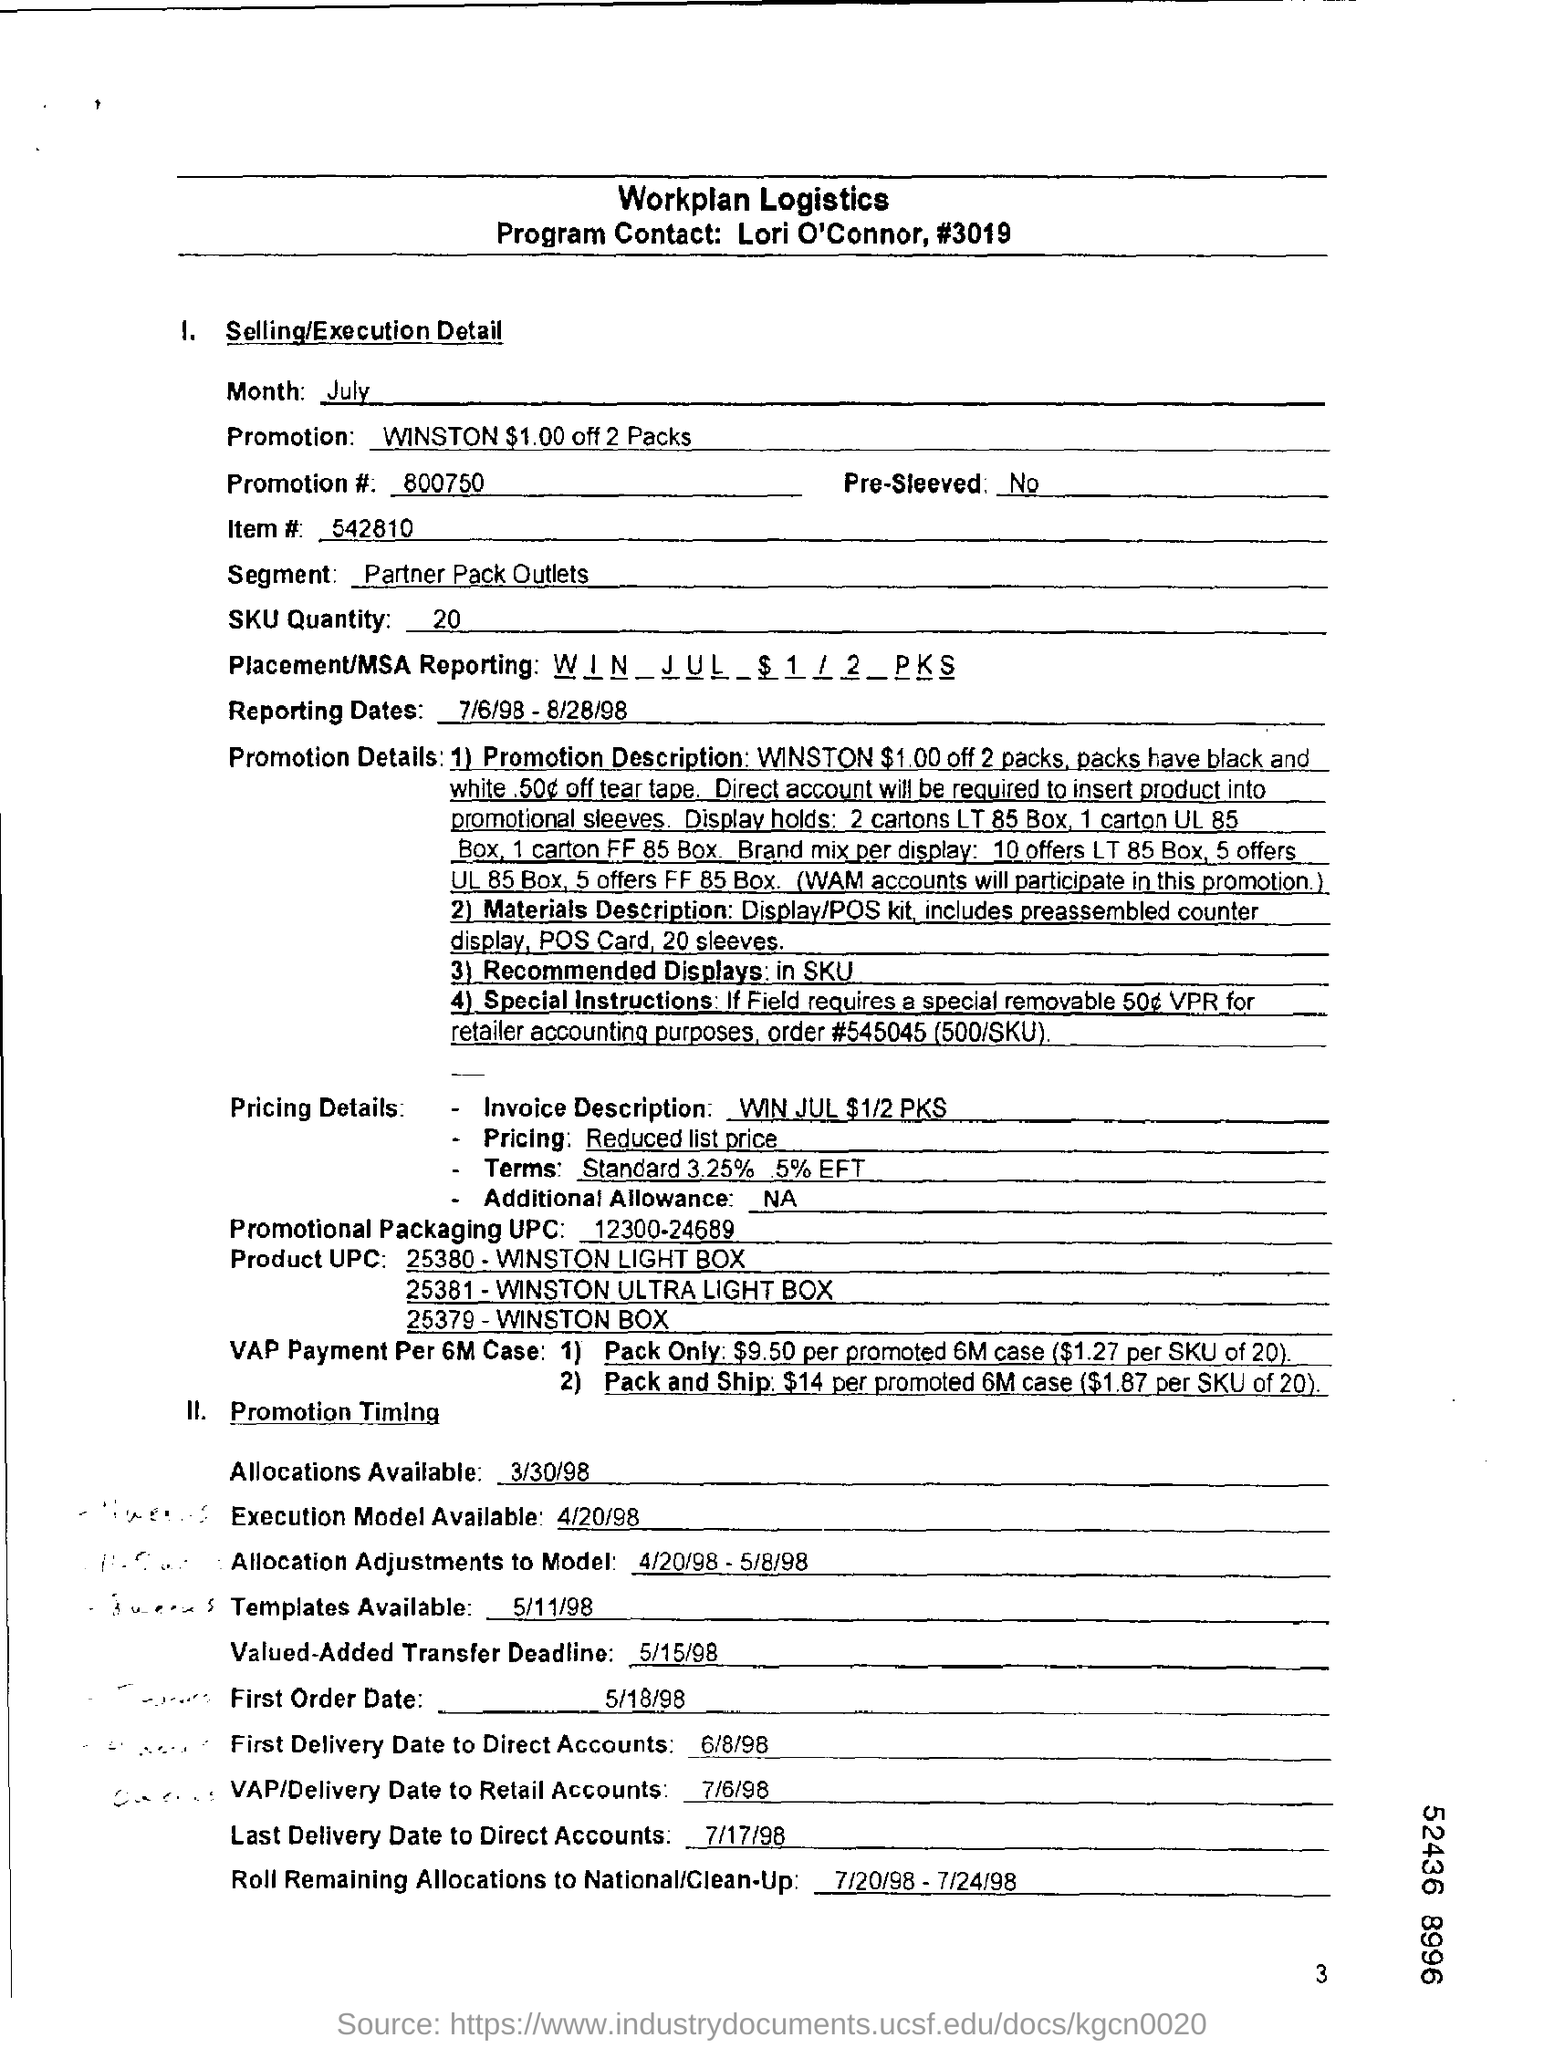Mention first order date?
Your answer should be very brief. 5/18/98. When are allocations available ?
Offer a terse response. 3/30/98. How much is the sku quantity ?
Your answer should be very brief. 20. Who is the program contact ?
Keep it short and to the point. Lori O'Connor. What is the segment under selling/executive detail?
Ensure brevity in your answer.  Partner Pack Outlets. What is the item#?
Provide a short and direct response. 542810. Is it pre-sleeved ?
Provide a succinct answer. No. 